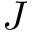Convert formula to latex. <formula><loc_0><loc_0><loc_500><loc_500>J</formula> 